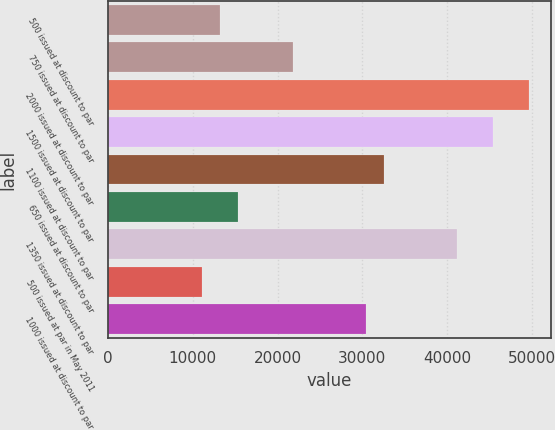Convert chart to OTSL. <chart><loc_0><loc_0><loc_500><loc_500><bar_chart><fcel>500 issued at discount to par<fcel>750 issued at discount to par<fcel>2000 issued at discount to par<fcel>1500 issued at discount to par<fcel>1100 issued at discount to par<fcel>650 issued at discount to par<fcel>1350 issued at discount to par<fcel>500 issued at par in May 2011<fcel>1000 issued at discount to par<nl><fcel>13199<fcel>21789<fcel>49706.5<fcel>45411.5<fcel>32526.5<fcel>15346.5<fcel>41116.5<fcel>11051.5<fcel>30379<nl></chart> 